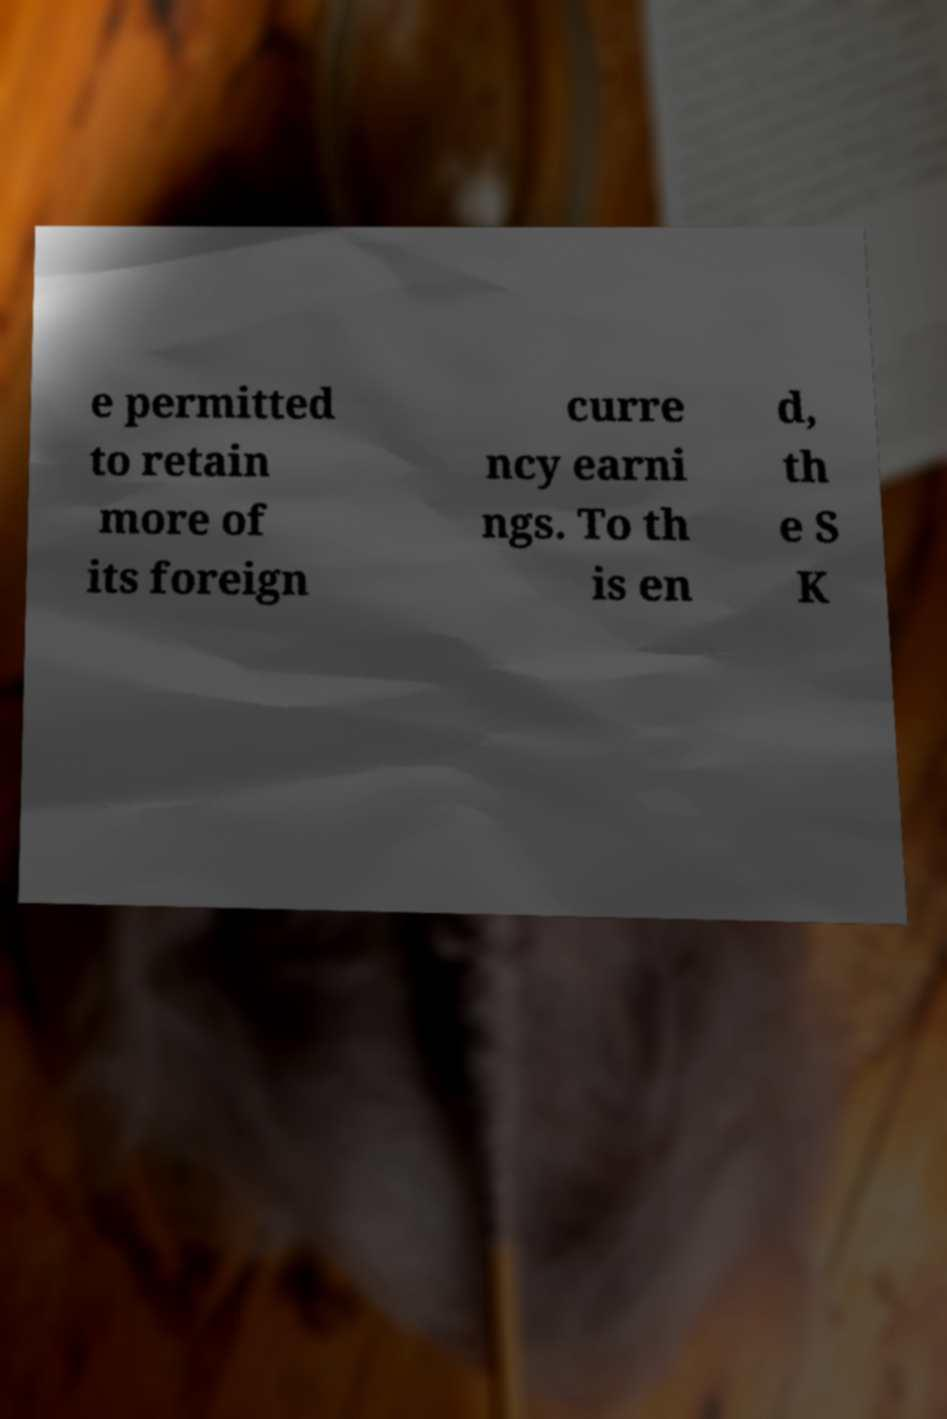Please read and relay the text visible in this image. What does it say? e permitted to retain more of its foreign curre ncy earni ngs. To th is en d, th e S K 